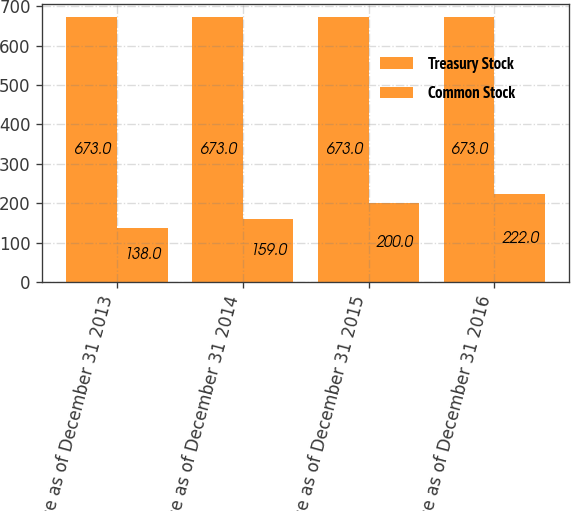Convert chart. <chart><loc_0><loc_0><loc_500><loc_500><stacked_bar_chart><ecel><fcel>Balance as of December 31 2013<fcel>Balance as of December 31 2014<fcel>Balance as of December 31 2015<fcel>Balance as of December 31 2016<nl><fcel>Treasury Stock<fcel>673<fcel>673<fcel>673<fcel>673<nl><fcel>Common Stock<fcel>138<fcel>159<fcel>200<fcel>222<nl></chart> 